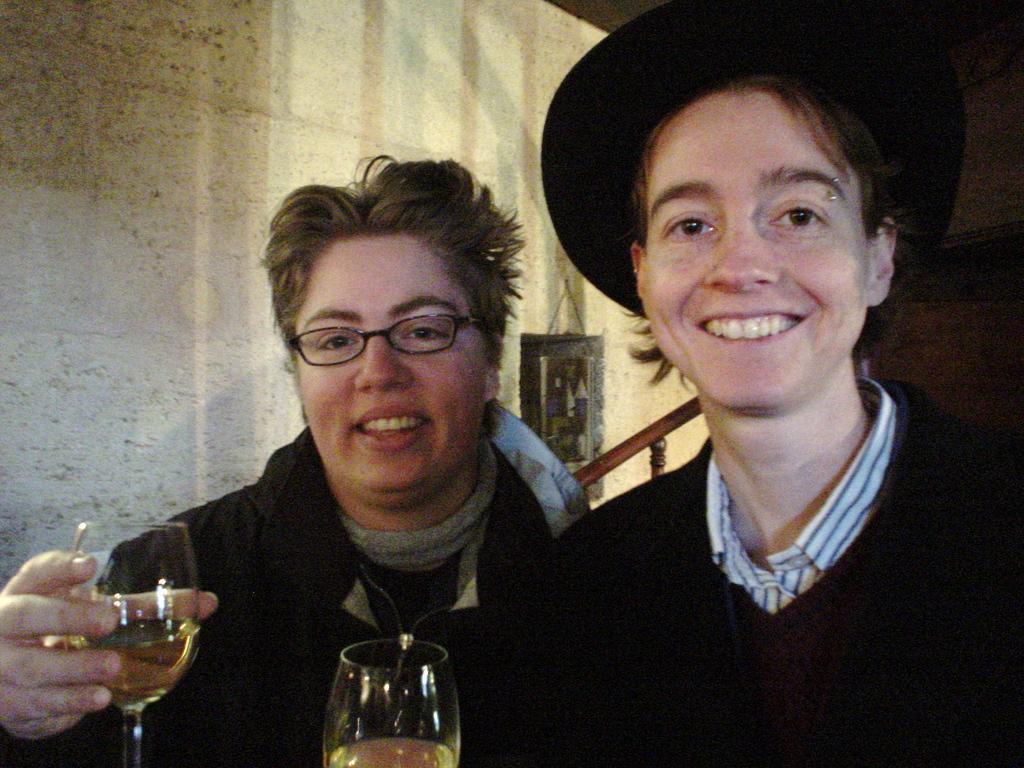Could you give a brief overview of what you see in this image? In the center of the image we can see two persons are holding a glass. In the background of the image we can see wall and stairs are there. 